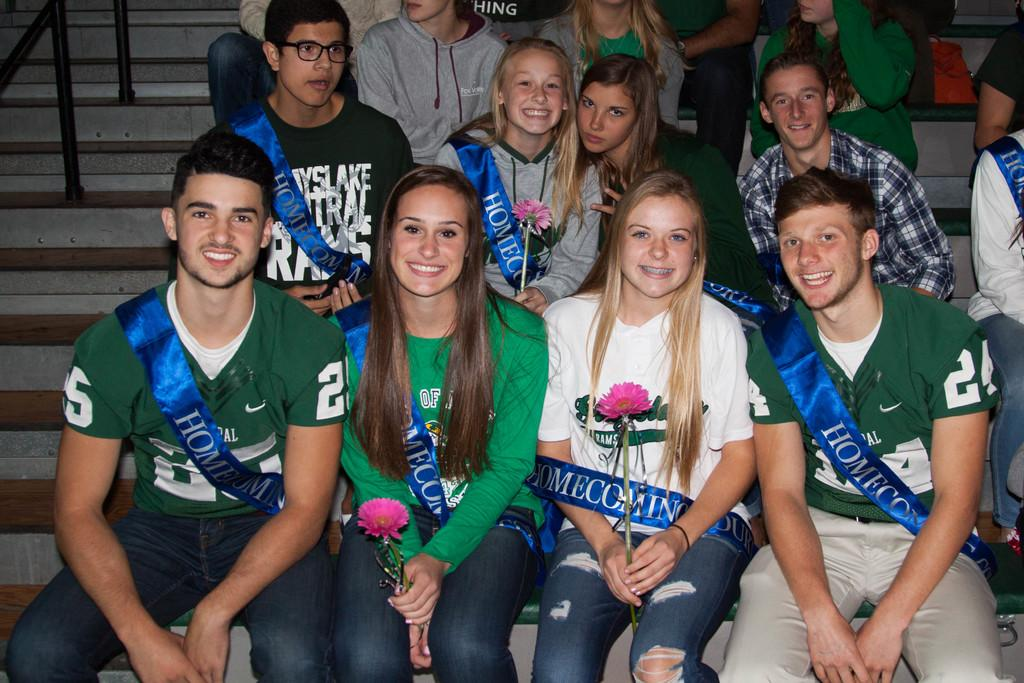Who or what can be seen in the image? There are people in the image. What are some of the people holding? Some people are holding flowers. Can you describe any architectural features in the image? There are stairs visible in the image. What color are the objects on the left side of the image? The objects on the left side of the image are black. What type of plantation is visible in the image? There is no plantation present in the image. What type of teaching is taking place in the image? There is no teaching or educational activity depicted in the image. 